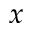<formula> <loc_0><loc_0><loc_500><loc_500>x</formula> 